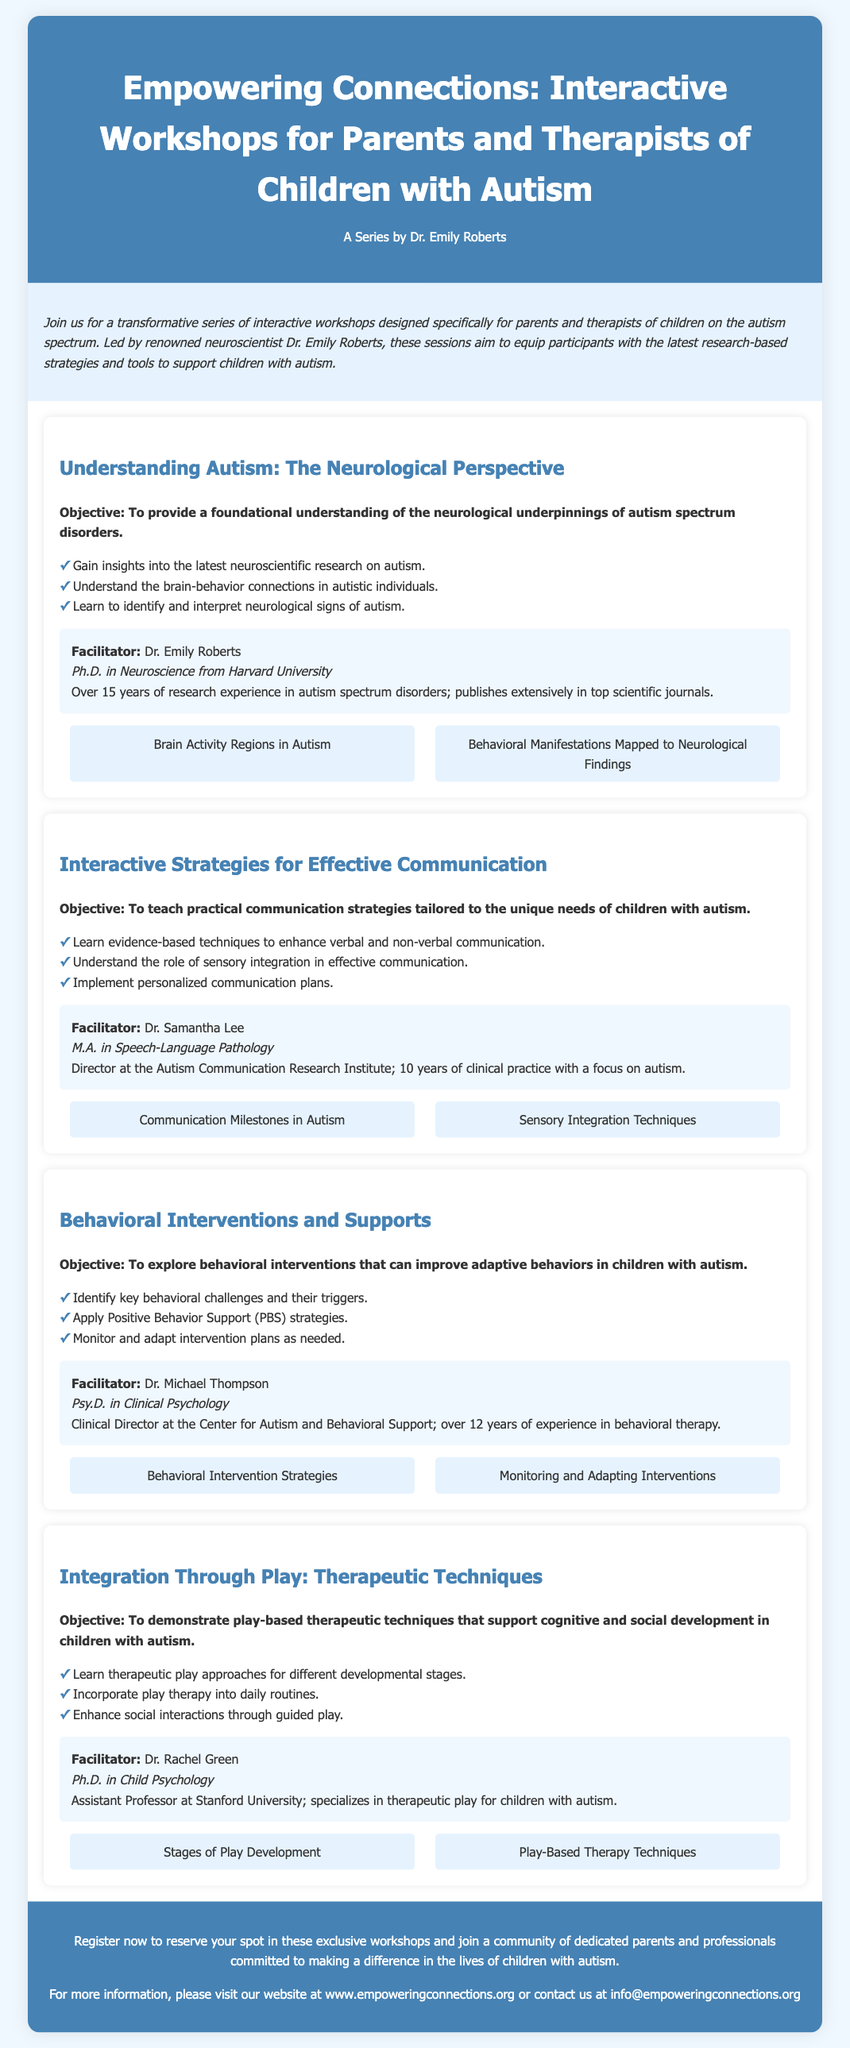What is the title of the workshop series? The title of the workshop series is presented prominently at the top of the document.
Answer: Empowering Connections: Interactive Workshops for Parents and Therapists of Children with Autism Who is the main facilitator of the workshop series? The main facilitator is mentioned in the header section of the document.
Answer: Dr. Emily Roberts How many workshops are featured in the Playbill? By counting the individual workshop sections in the document, the total number of workshops can be determined.
Answer: Four What is the objective of the workshop on effective communication? The objective is stated clearly under the workshop's title, summarizing its purpose.
Answer: To teach practical communication strategies tailored to the unique needs of children with autism Which facilitator specializes in therapeutic play? Each workshop lists its facilitator; the one who specializes in therapeutic play is stated in the appropriate workshop section.
Answer: Dr. Rachel Green What major theme is common among all workshops? Analyzing the workshop descriptions indicates a common theme relevant to supporting children with autism.
Answer: Support for children with autism 